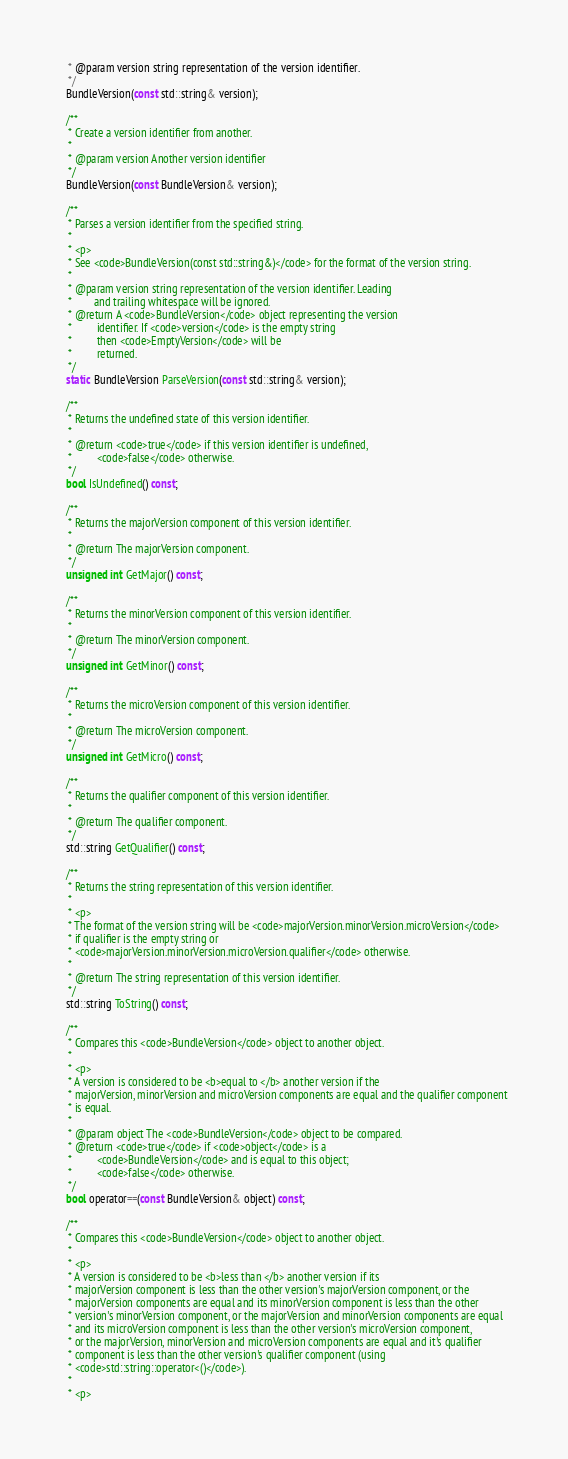<code> <loc_0><loc_0><loc_500><loc_500><_C_>   * @param version string representation of the version identifier.
   */
  BundleVersion(const std::string& version);

  /**
   * Create a version identifier from another.
   *
   * @param version Another version identifier
   */
  BundleVersion(const BundleVersion& version);

  /**
   * Parses a version identifier from the specified string.
   *
   * <p>
   * See <code>BundleVersion(const std::string&)</code> for the format of the version string.
   *
   * @param version string representation of the version identifier. Leading
   *        and trailing whitespace will be ignored.
   * @return A <code>BundleVersion</code> object representing the version
   *         identifier. If <code>version</code> is the empty string
   *         then <code>EmptyVersion</code> will be
   *         returned.
   */
  static BundleVersion ParseVersion(const std::string& version);

  /**
   * Returns the undefined state of this version identifier.
   *
   * @return <code>true</code> if this version identifier is undefined,
   *         <code>false</code> otherwise.
   */
  bool IsUndefined() const;

  /**
   * Returns the majorVersion component of this version identifier.
   *
   * @return The majorVersion component.
   */
  unsigned int GetMajor() const;

  /**
   * Returns the minorVersion component of this version identifier.
   *
   * @return The minorVersion component.
   */
  unsigned int GetMinor() const;

  /**
   * Returns the microVersion component of this version identifier.
   *
   * @return The microVersion component.
   */
  unsigned int GetMicro() const;

  /**
   * Returns the qualifier component of this version identifier.
   *
   * @return The qualifier component.
   */
  std::string GetQualifier() const;

  /**
   * Returns the string representation of this version identifier.
   *
   * <p>
   * The format of the version string will be <code>majorVersion.minorVersion.microVersion</code>
   * if qualifier is the empty string or
   * <code>majorVersion.minorVersion.microVersion.qualifier</code> otherwise.
   *
   * @return The string representation of this version identifier.
   */
  std::string ToString() const;

  /**
   * Compares this <code>BundleVersion</code> object to another object.
   *
   * <p>
   * A version is considered to be <b>equal to </b> another version if the
   * majorVersion, minorVersion and microVersion components are equal and the qualifier component
   * is equal.
   *
   * @param object The <code>BundleVersion</code> object to be compared.
   * @return <code>true</code> if <code>object</code> is a
   *         <code>BundleVersion</code> and is equal to this object;
   *         <code>false</code> otherwise.
   */
  bool operator==(const BundleVersion& object) const;

  /**
   * Compares this <code>BundleVersion</code> object to another object.
   *
   * <p>
   * A version is considered to be <b>less than </b> another version if its
   * majorVersion component is less than the other version's majorVersion component, or the
   * majorVersion components are equal and its minorVersion component is less than the other
   * version's minorVersion component, or the majorVersion and minorVersion components are equal
   * and its microVersion component is less than the other version's microVersion component,
   * or the majorVersion, minorVersion and microVersion components are equal and it's qualifier
   * component is less than the other version's qualifier component (using
   * <code>std::string::operator<()</code>).
   *
   * <p></code> 